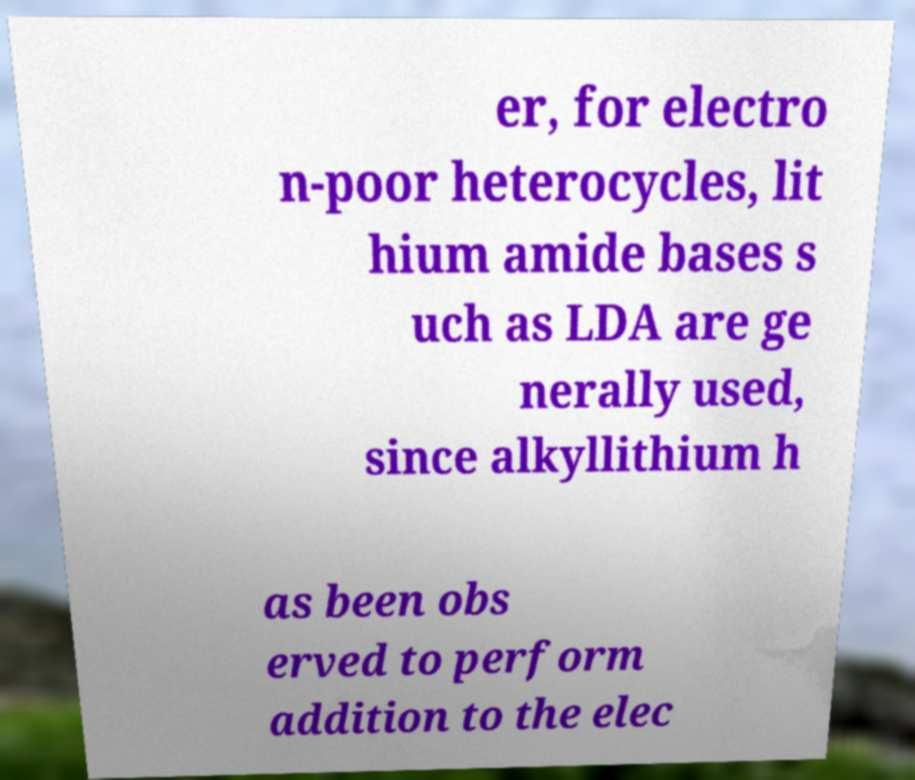I need the written content from this picture converted into text. Can you do that? er, for electro n-poor heterocycles, lit hium amide bases s uch as LDA are ge nerally used, since alkyllithium h as been obs erved to perform addition to the elec 